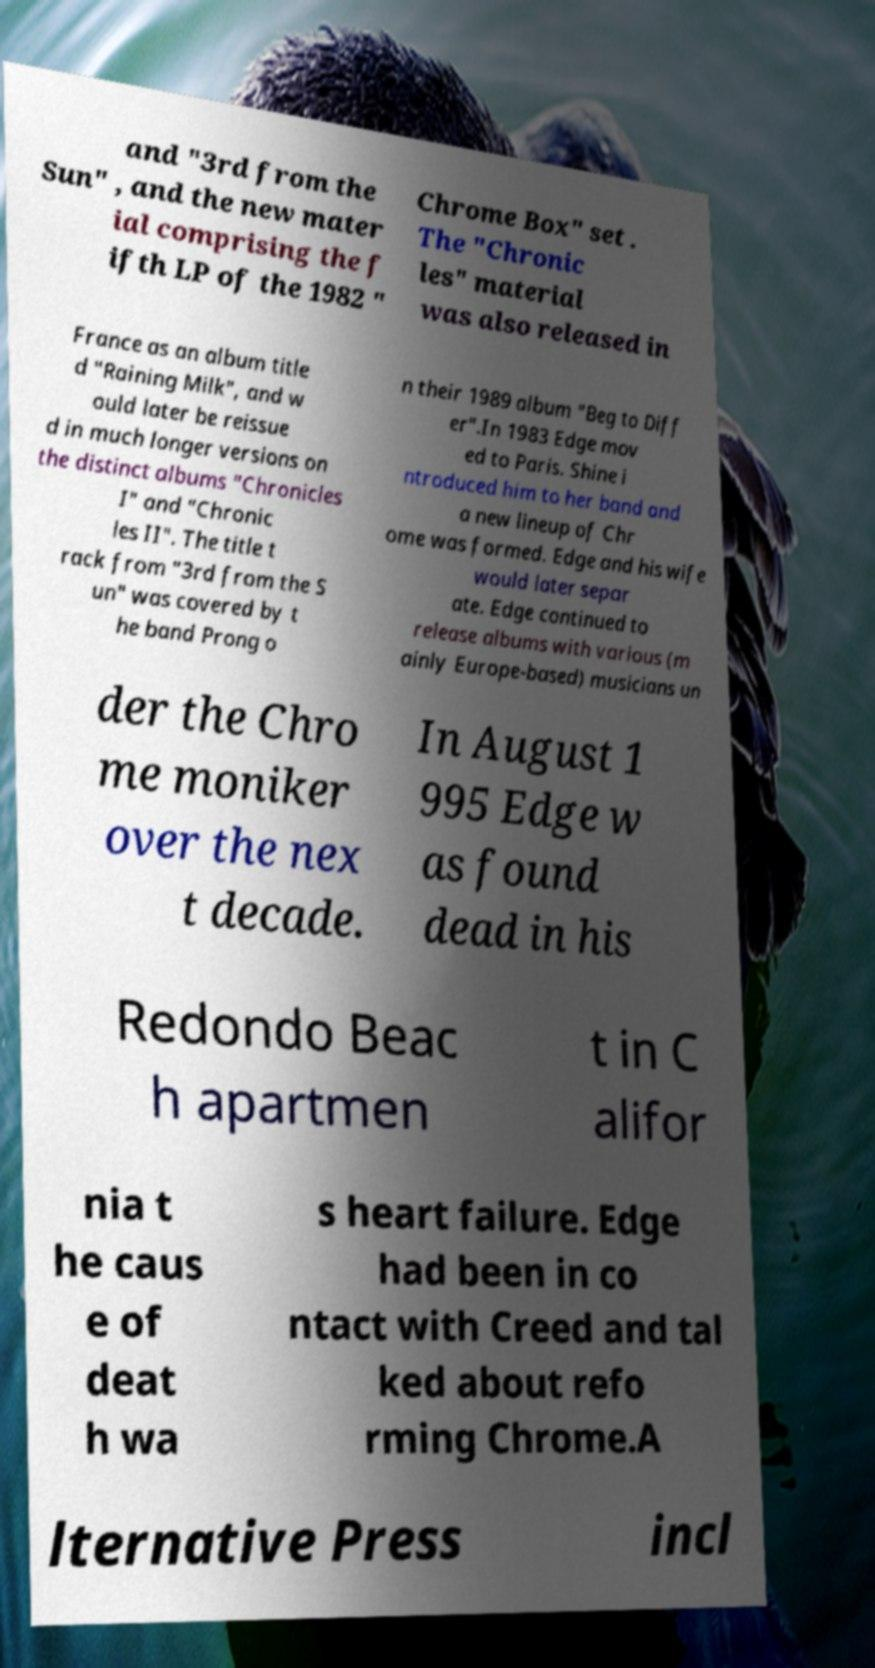I need the written content from this picture converted into text. Can you do that? and "3rd from the Sun" , and the new mater ial comprising the f ifth LP of the 1982 " Chrome Box" set . The "Chronic les" material was also released in France as an album title d "Raining Milk", and w ould later be reissue d in much longer versions on the distinct albums "Chronicles I" and "Chronic les II". The title t rack from "3rd from the S un" was covered by t he band Prong o n their 1989 album "Beg to Diff er".In 1983 Edge mov ed to Paris. Shine i ntroduced him to her band and a new lineup of Chr ome was formed. Edge and his wife would later separ ate. Edge continued to release albums with various (m ainly Europe-based) musicians un der the Chro me moniker over the nex t decade. In August 1 995 Edge w as found dead in his Redondo Beac h apartmen t in C alifor nia t he caus e of deat h wa s heart failure. Edge had been in co ntact with Creed and tal ked about refo rming Chrome.A lternative Press incl 